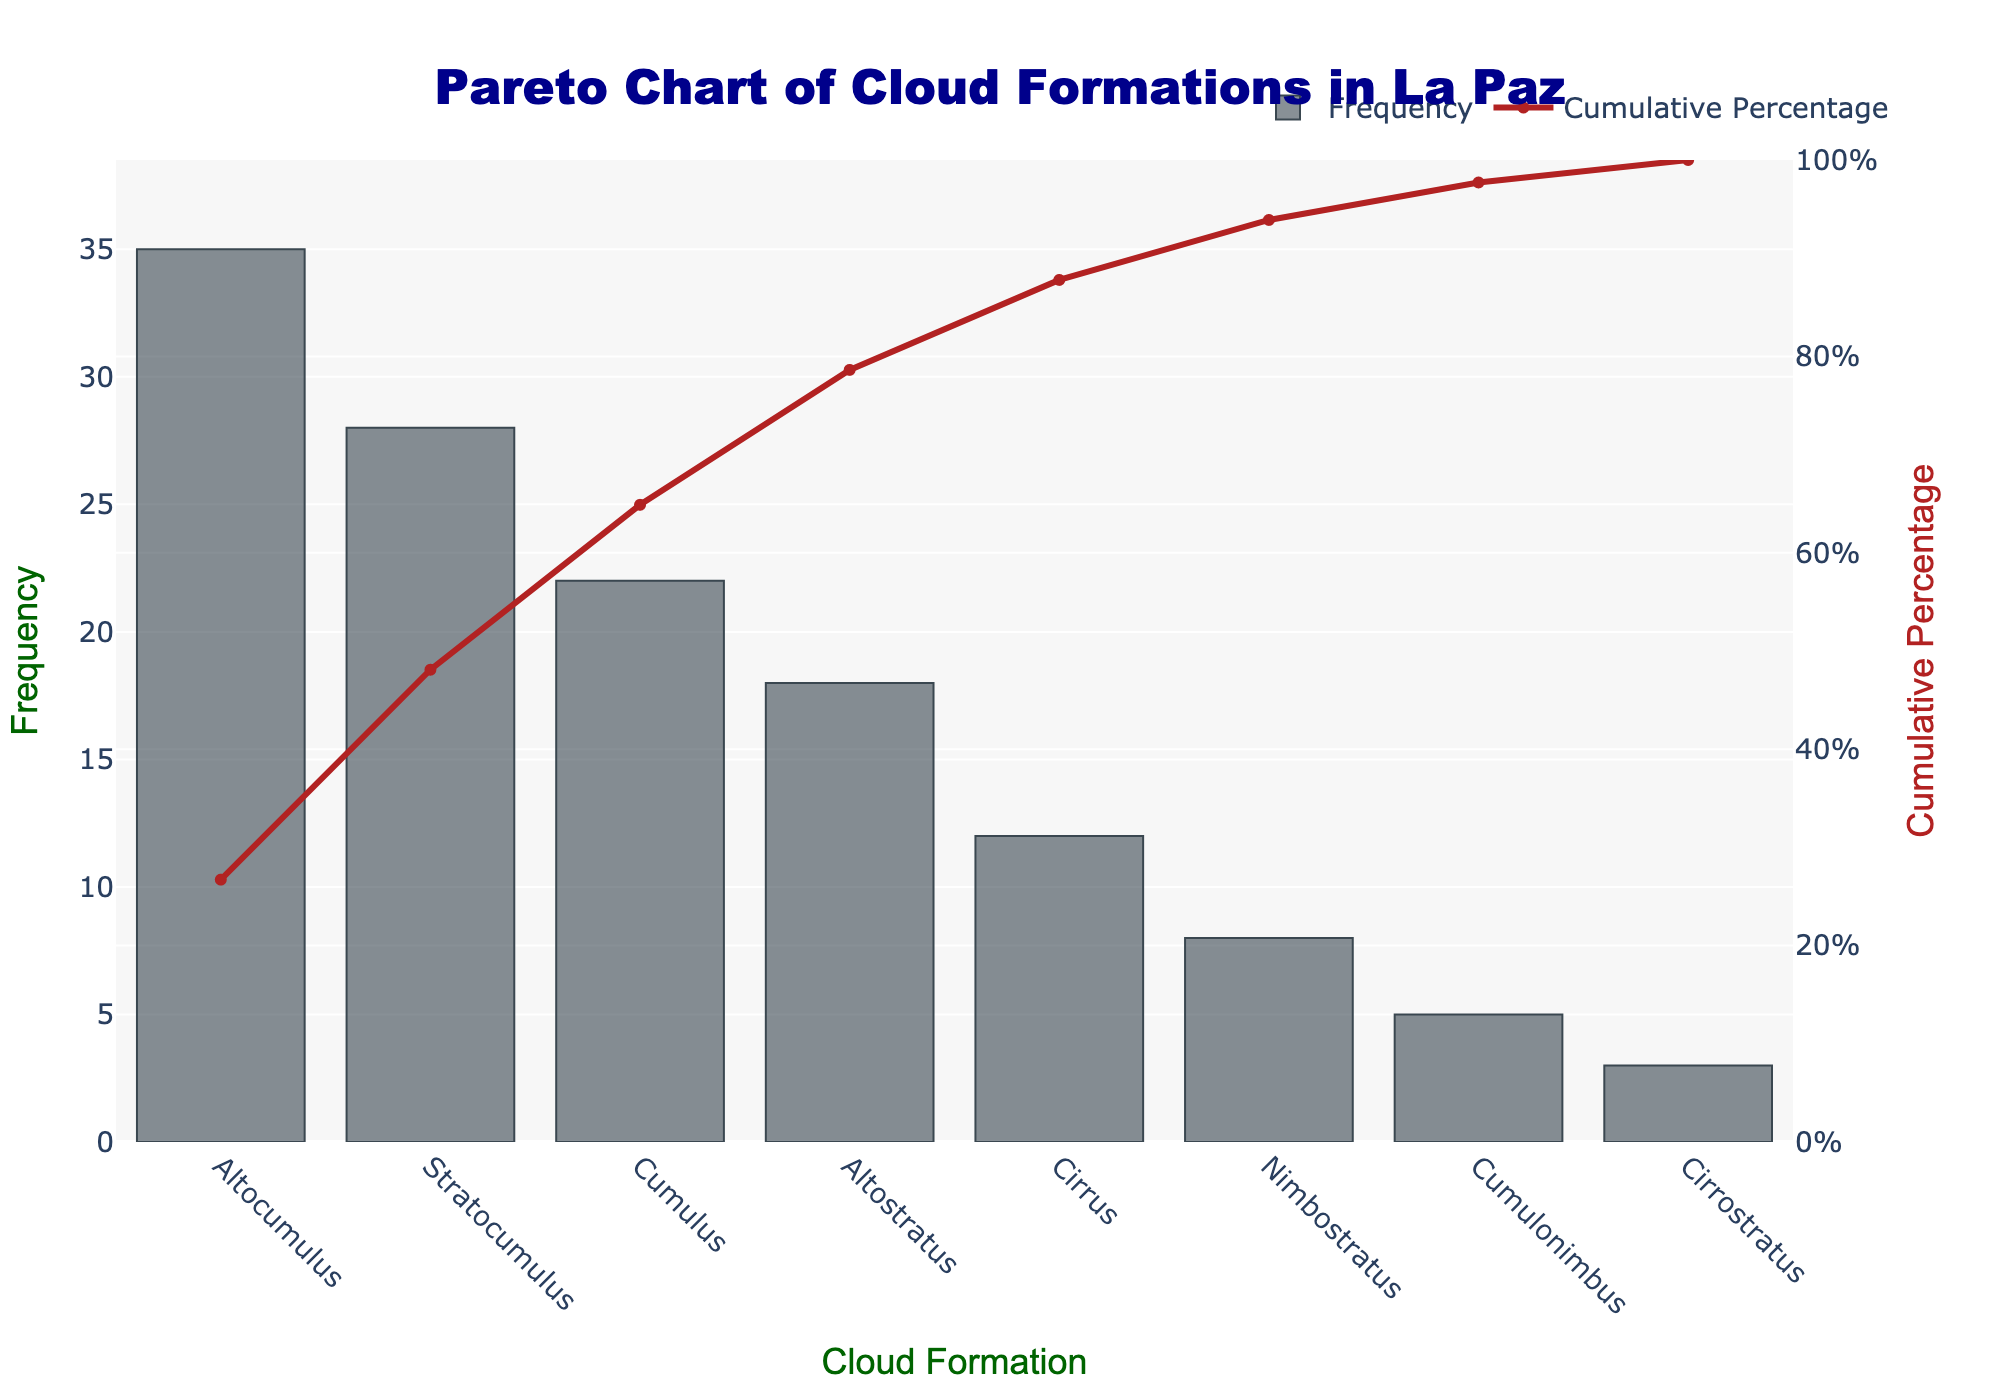What is the title of the chart? The title of the chart is usually placed at the top and centered. For this chart, it reads "Pareto Chart of Cloud Formations in La Paz".
Answer: Pareto Chart of Cloud Formations in La Paz Which cloud formation has the highest frequency? Look at the x-axis for the cloud formations and note the bar with the highest value on the y-axis. The tallest bar corresponds to "Altocumulus".
Answer: Altocumulus How many cloud formations have a frequency of more than 20? Examine the y-axis and identify the bars that exceed the value of 20. These are "Altocumulus", "Stratocumulus", and "Cumulus".
Answer: 3 What is the cumulative percentage after the third most frequent cloud formation? To find the cumulative percentage for "Cumulus" (the third bar), refer to the second y-axis and the corresponding line plot. The value is near 53%.
Answer: 53% How much more frequent is Altocumulus compared to Cirrus? Find the heights of the bars for "Altocumulus" and "Cirrus" on the y-axis. "Altocumulus" is at 35, and "Cirrus" is at 12. The difference is 35 - 12 = 23.
Answer: 23 What percentage of cloud observations do the top three cloud formations constitute? Calculate the cumulative percentage up to the third bar, "Cumulus". The cumulative percentage is around 53%.
Answer: 53% Which cloud formations constitute the bottom 20% of occurrences? Locate the cumulative percentage axis and note where it reaches 80%, the formations beyond this point are the bottom 20%. These include "Cirrostratus" and "Cumulonimbus".
Answer: Cirrostratus and Cumulonimbus How does the frequency of Altostratus compare to Stratocumulus? Look at the heights of the bars for "Altostratus" and "Stratocumulus". "Altostratus" is at 18 and "Stratocumulus" is at 28, meaning "Stratocumulus" is more frequent by 28 - 18 = 10.
Answer: Stratocumulus is more frequent by 10 What is the cumulative percentage after the fifth most frequent cloud formation? Identify the fifth bar "Cirrus" and find the associated point on the cumulative percentage line plot. The value is around 85%.
Answer: 85% What is the color of the cumulative percentage line? The cumulative percentage line is drawn in a specific color for easy distinction; in this chart, it is colored "firebrick" (a shade of red).
Answer: Firebrick 